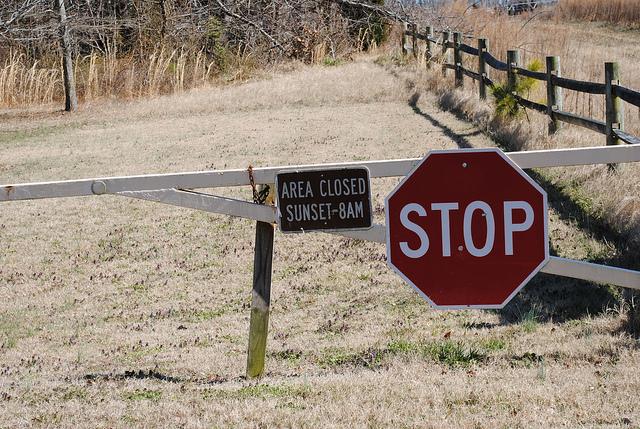What color is the grass?
Be succinct. Brown. What kind of fence is that?
Quick response, please. Wood. What does the sign next to the stop sign read?
Quick response, please. Area closed sunset-8am. Does this stop sign need to be painted?
Quick response, please. No. 